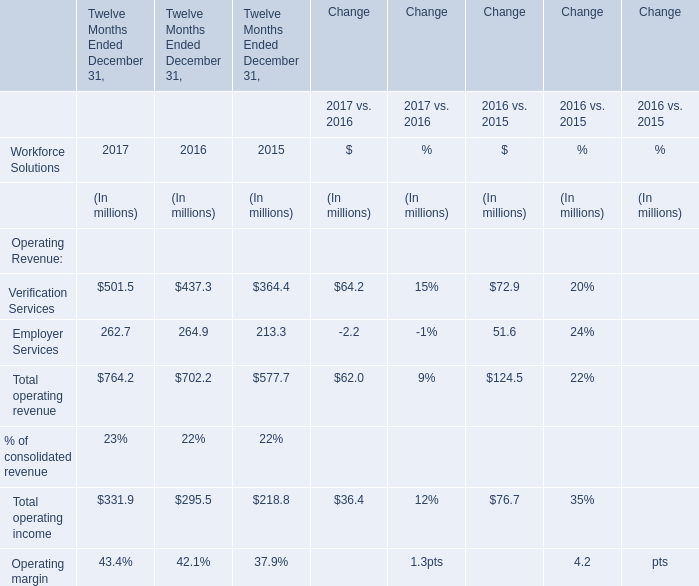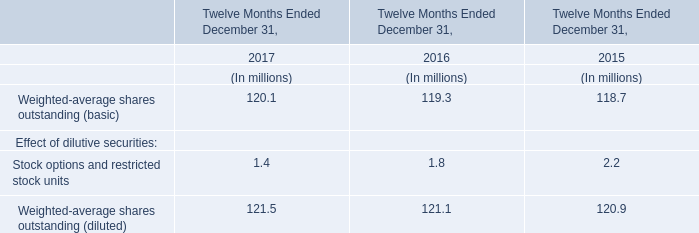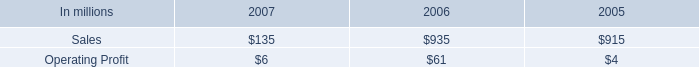In the year with the most Verification Services, what is the growth rate of Employer Services? 
Computations: ((262.7 - 264.9) / 264.9)
Answer: -0.00831. 